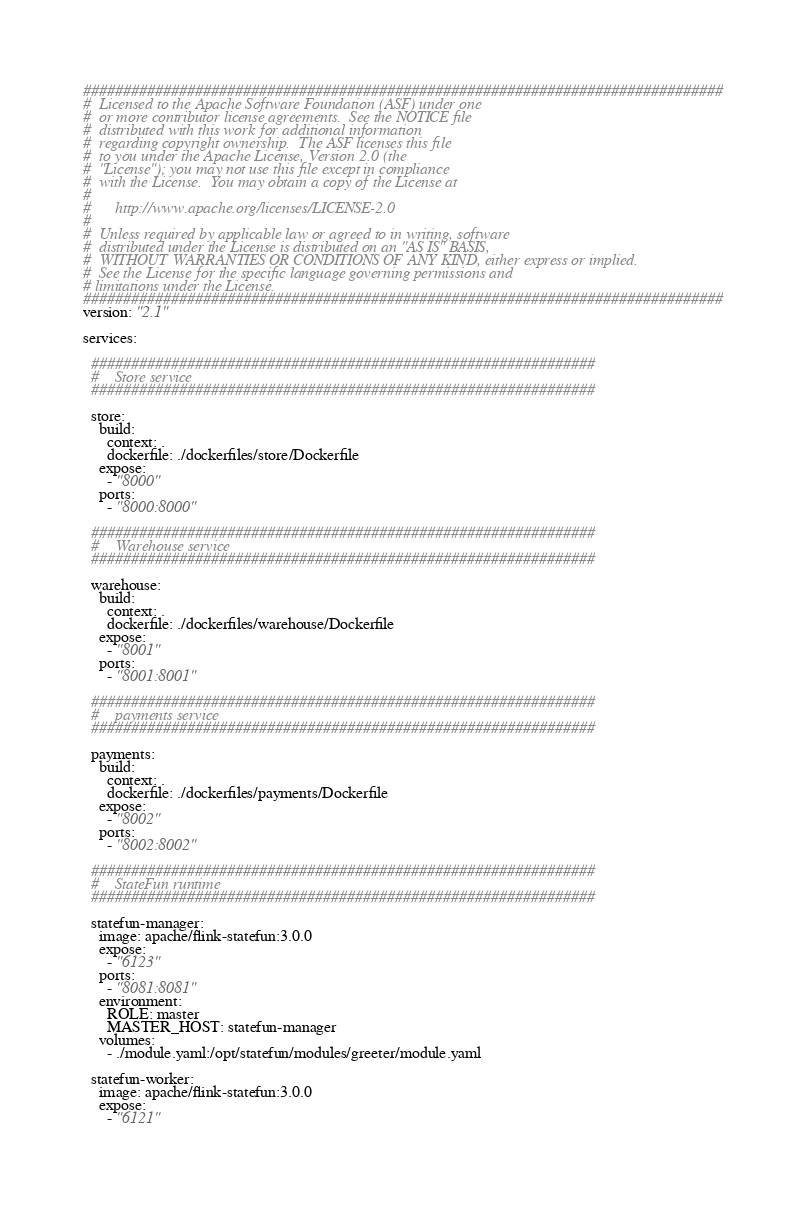<code> <loc_0><loc_0><loc_500><loc_500><_YAML_>################################################################################
#  Licensed to the Apache Software Foundation (ASF) under one
#  or more contributor license agreements.  See the NOTICE file
#  distributed with this work for additional information
#  regarding copyright ownership.  The ASF licenses this file
#  to you under the Apache License, Version 2.0 (the
#  "License"); you may not use this file except in compliance
#  with the License.  You may obtain a copy of the License at
#
#      http://www.apache.org/licenses/LICENSE-2.0
#
#  Unless required by applicable law or agreed to in writing, software
#  distributed under the License is distributed on an "AS IS" BASIS,
#  WITHOUT WARRANTIES OR CONDITIONS OF ANY KIND, either express or implied.
#  See the License for the specific language governing permissions and
# limitations under the License.
################################################################################
version: "2.1"

services:

  ###############################################################
  #    Store service
  ###############################################################

  store:
    build:
      context: .
      dockerfile: ./dockerfiles/store/Dockerfile
    expose:
      - "8000"
    ports:
      - "8000:8000"

  ###############################################################
  #    Warehouse service
  ###############################################################

  warehouse:
    build:
      context: .
      dockerfile: ./dockerfiles/warehouse/Dockerfile
    expose:
      - "8001"
    ports:
      - "8001:8001"

  ###############################################################
  #    payments service
  ###############################################################

  payments:
    build:
      context: .
      dockerfile: ./dockerfiles/payments/Dockerfile
    expose:
      - "8002"
    ports:
      - "8002:8002"

  ###############################################################
  #    StateFun runtime
  ###############################################################

  statefun-manager:
    image: apache/flink-statefun:3.0.0
    expose:
      - "6123"
    ports:
      - "8081:8081"
    environment:
      ROLE: master
      MASTER_HOST: statefun-manager
    volumes:
      - ./module.yaml:/opt/statefun/modules/greeter/module.yaml

  statefun-worker:
    image: apache/flink-statefun:3.0.0
    expose:
      - "6121"</code> 